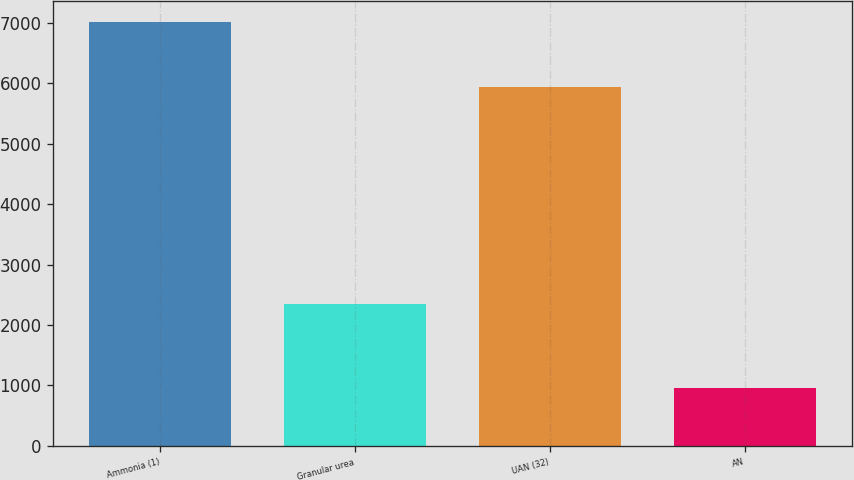Convert chart to OTSL. <chart><loc_0><loc_0><loc_500><loc_500><bar_chart><fcel>Ammonia (1)<fcel>Granular urea<fcel>UAN (32)<fcel>AN<nl><fcel>7011<fcel>2347<fcel>5939<fcel>950<nl></chart> 